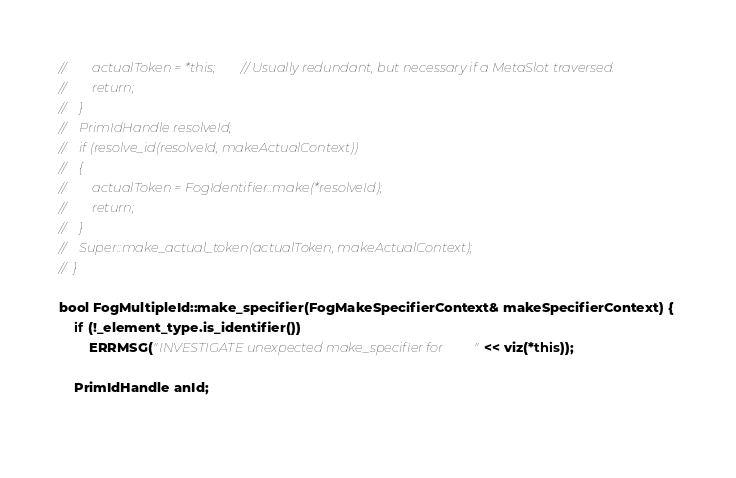Convert code to text. <code><loc_0><loc_0><loc_500><loc_500><_C++_>//        actualToken = *this;        // Usually redundant, but necessary if a MetaSlot traversed.
//        return;
//    }
//    PrimIdHandle resolveId;
//    if (resolve_id(resolveId, makeActualContext))
//    {
//        actualToken = FogIdentifier::make(*resolveId);
//        return;
//    }
//    Super::make_actual_token(actualToken, makeActualContext);
//  }

bool FogMultipleId::make_specifier(FogMakeSpecifierContext& makeSpecifierContext) {
	if (!_element_type.is_identifier())
		ERRMSG("INVESTIGATE unexpected make_specifier for " << viz(*this));
		
	PrimIdHandle anId;
	</code> 